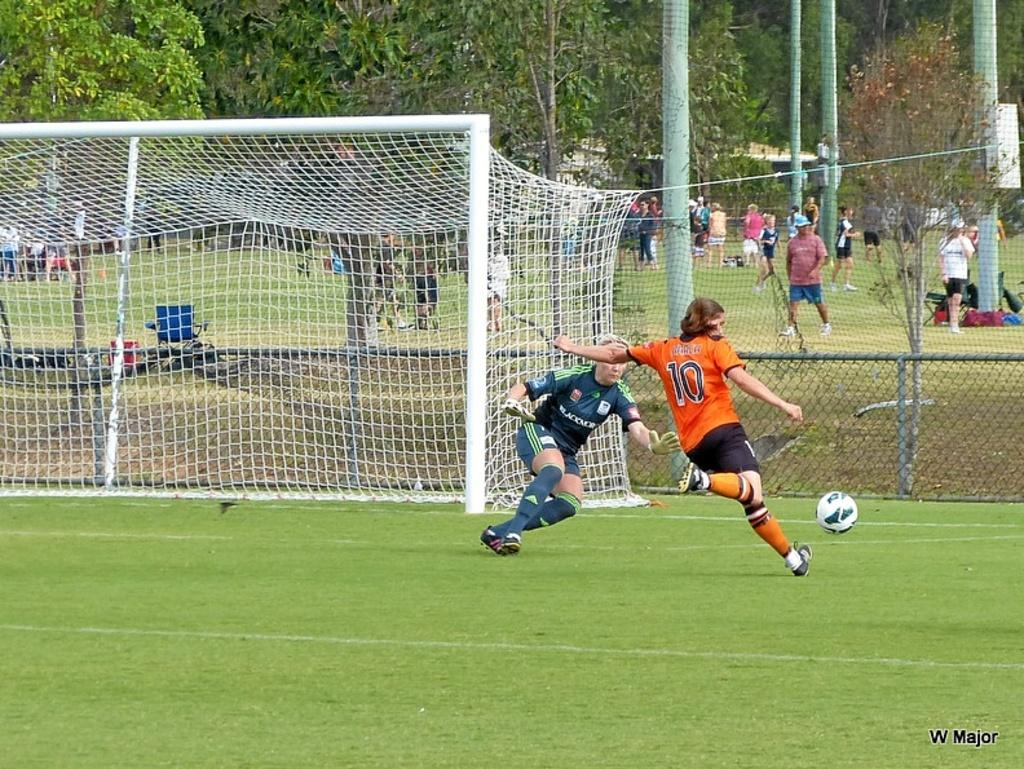<image>
Offer a succinct explanation of the picture presented. Player number 10 is about to kick the soccer ball toward the goal. 